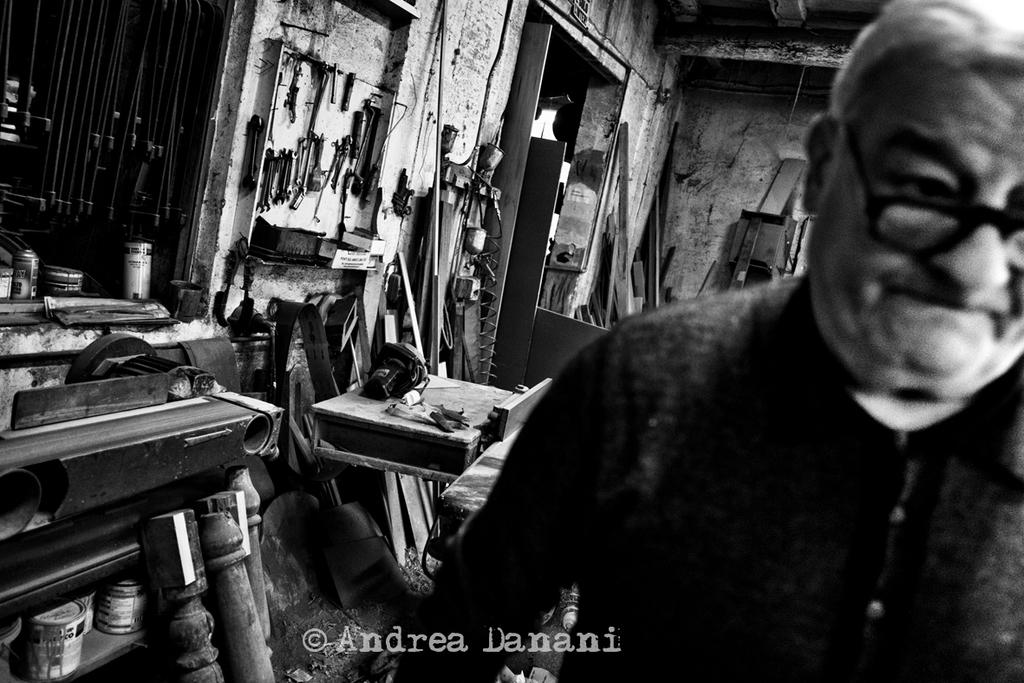What is the color scheme of the image? The image is black and white. Who or what can be seen in the image? There is a man in the image. What type of structures are present in the image? There are walls in the image. What material is used for some of the objects in the image? There are wooden planks in the image. What type of items can be seen in the image? There are bottles in the image. Is there any text present in the image? Yes, there is some text in the image. Can you describe any other objects in the image? There are some objects in the image, but their specific details are not mentioned in the provided facts. What type of crime is being committed in the image? There is no indication of any crime being committed in the image. The image features a man, walls, wooden planks, bottles, text, and other objects, but no crime is depicted. 